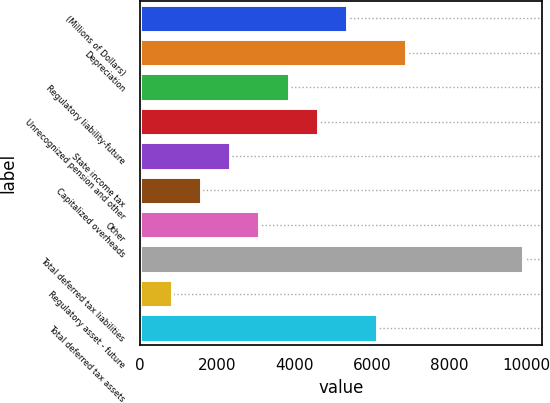Convert chart to OTSL. <chart><loc_0><loc_0><loc_500><loc_500><bar_chart><fcel>(Millions of Dollars)<fcel>Depreciation<fcel>Regulatory liability-future<fcel>Unrecognized pension and other<fcel>State income tax<fcel>Capitalized overheads<fcel>Other<fcel>Total deferred tax liabilities<fcel>Regulatory asset - future<fcel>Total deferred tax assets<nl><fcel>5367.8<fcel>6882.6<fcel>3853<fcel>4610.4<fcel>2338.2<fcel>1580.8<fcel>3095.6<fcel>9912.2<fcel>823.4<fcel>6125.2<nl></chart> 